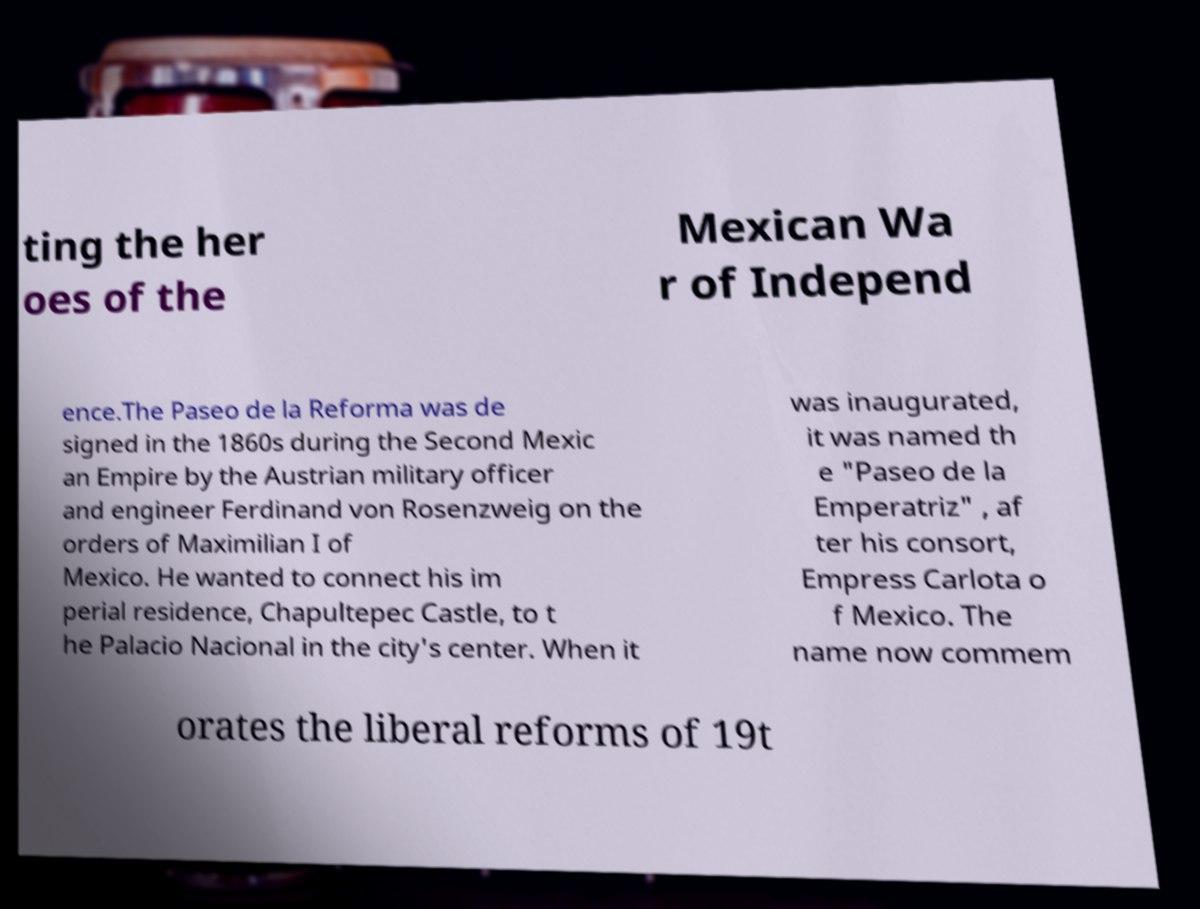Could you extract and type out the text from this image? ting the her oes of the Mexican Wa r of Independ ence.The Paseo de la Reforma was de signed in the 1860s during the Second Mexic an Empire by the Austrian military officer and engineer Ferdinand von Rosenzweig on the orders of Maximilian I of Mexico. He wanted to connect his im perial residence, Chapultepec Castle, to t he Palacio Nacional in the city's center. When it was inaugurated, it was named th e "Paseo de la Emperatriz" , af ter his consort, Empress Carlota o f Mexico. The name now commem orates the liberal reforms of 19t 